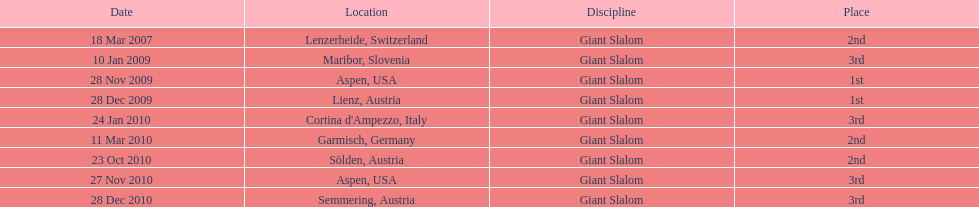How many races were in 2010? 5. 